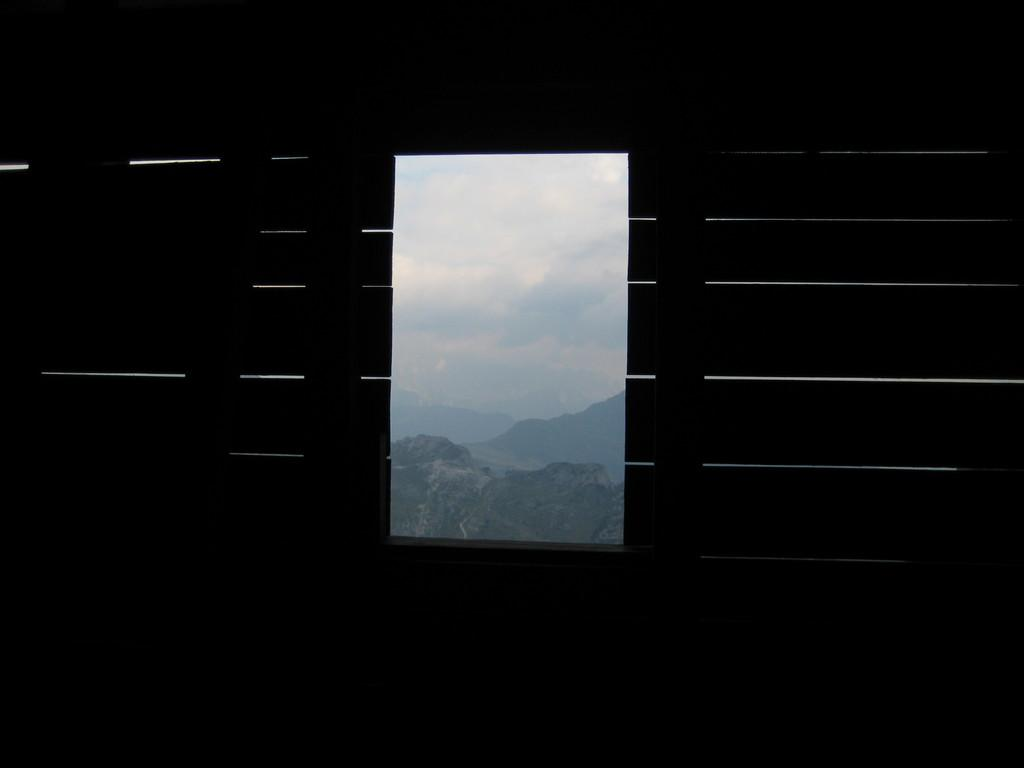What is present in the image that provides a view of the outside? There is a window in the image. What can be seen through the window? Mountains, clouds, and the sky are visible through the window. What type of rose is being used as a weapon in the battle depicted in the image? There is no rose or battle present in the image; it only features a window with a view of mountains, clouds, and the sky. 